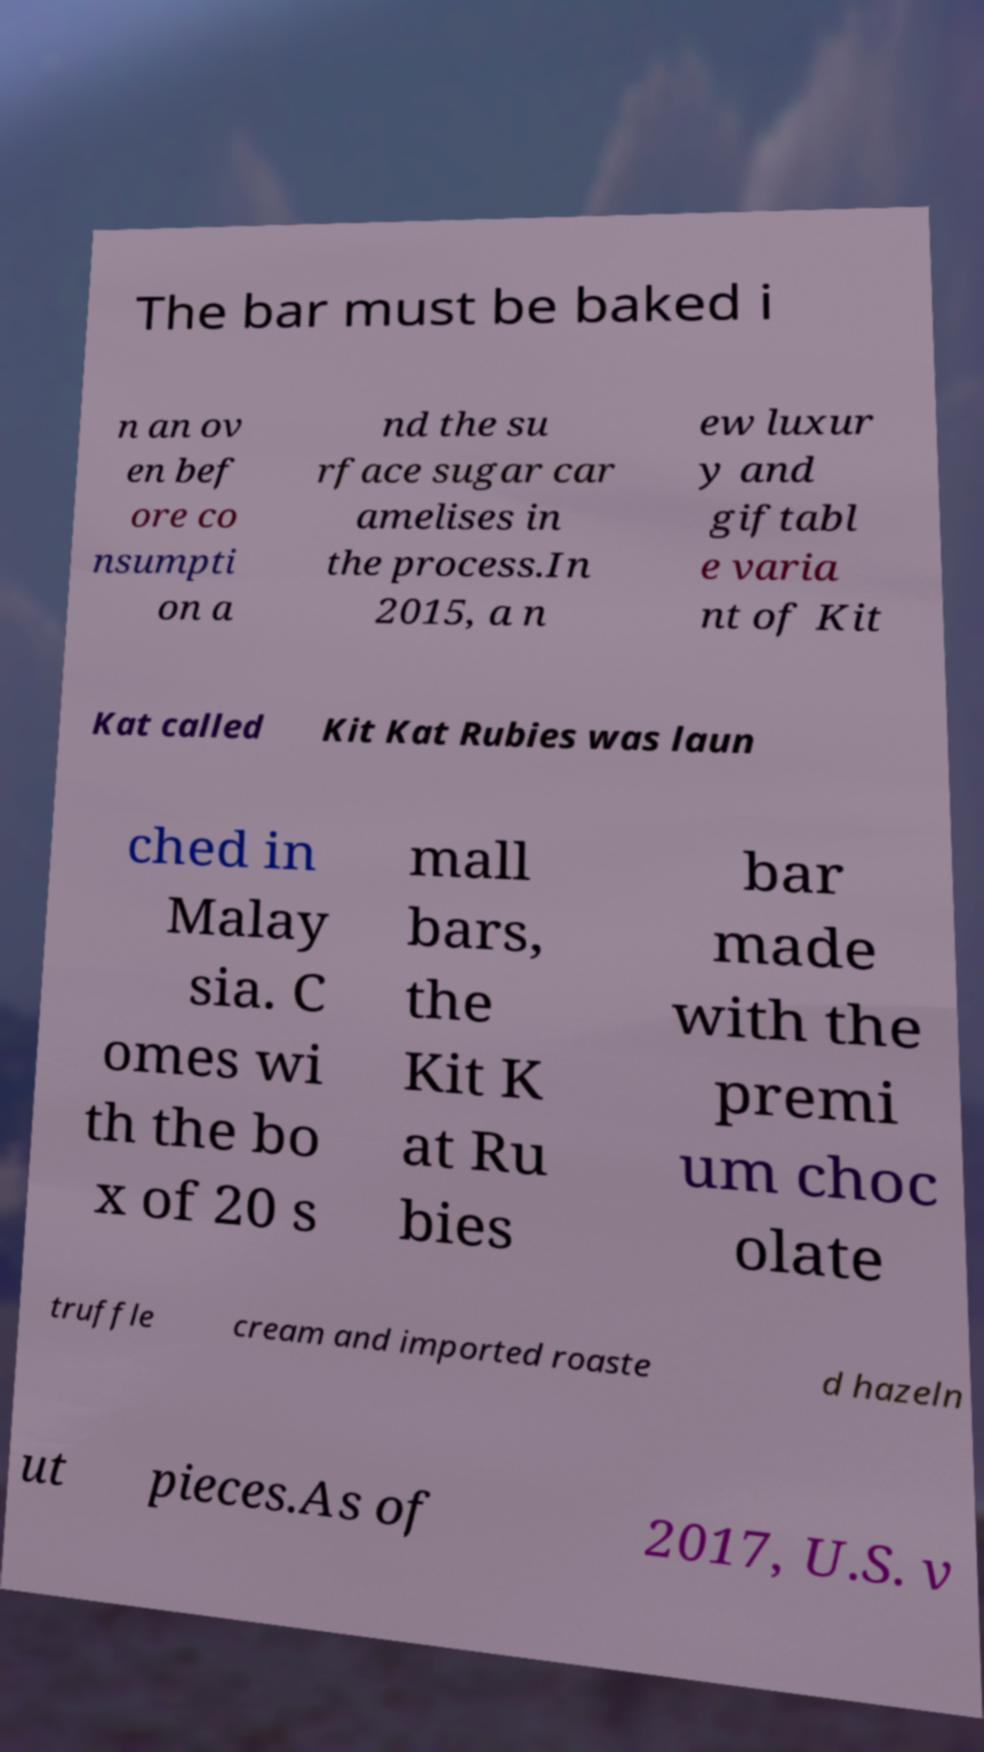There's text embedded in this image that I need extracted. Can you transcribe it verbatim? The bar must be baked i n an ov en bef ore co nsumpti on a nd the su rface sugar car amelises in the process.In 2015, a n ew luxur y and giftabl e varia nt of Kit Kat called Kit Kat Rubies was laun ched in Malay sia. C omes wi th the bo x of 20 s mall bars, the Kit K at Ru bies bar made with the premi um choc olate truffle cream and imported roaste d hazeln ut pieces.As of 2017, U.S. v 